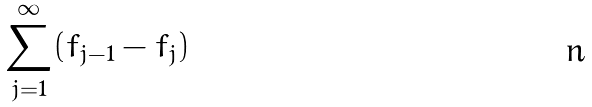<formula> <loc_0><loc_0><loc_500><loc_500>\sum _ { j = 1 } ^ { \infty } ( f _ { j - 1 } - f _ { j } )</formula> 